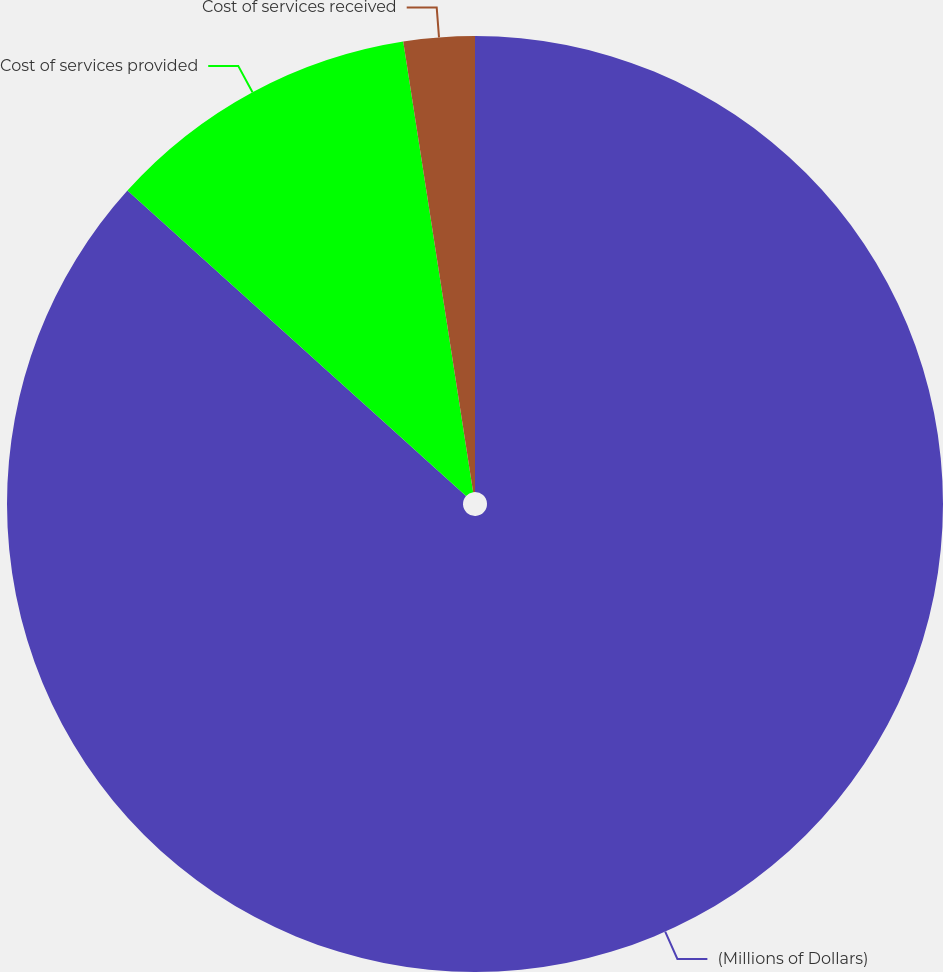Convert chart to OTSL. <chart><loc_0><loc_0><loc_500><loc_500><pie_chart><fcel>(Millions of Dollars)<fcel>Cost of services provided<fcel>Cost of services received<nl><fcel>86.67%<fcel>10.87%<fcel>2.45%<nl></chart> 